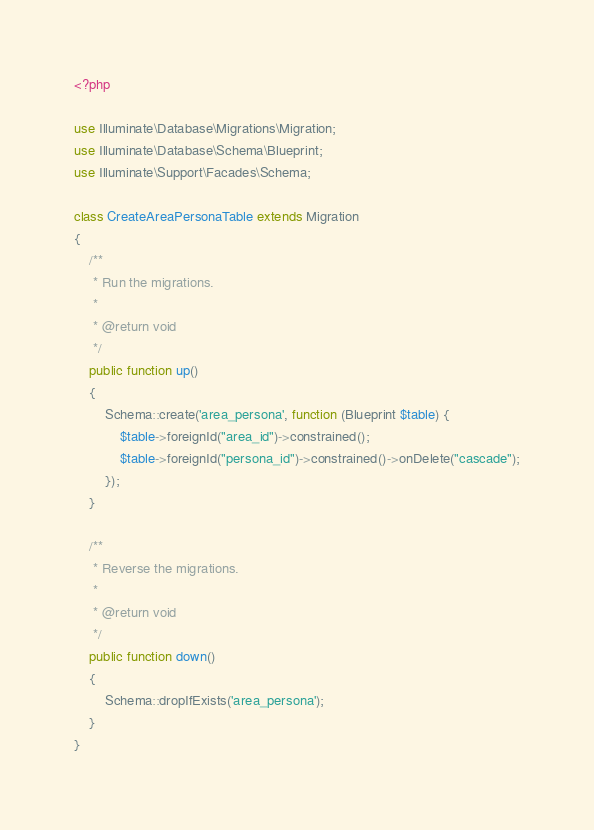Convert code to text. <code><loc_0><loc_0><loc_500><loc_500><_PHP_><?php

use Illuminate\Database\Migrations\Migration;
use Illuminate\Database\Schema\Blueprint;
use Illuminate\Support\Facades\Schema;

class CreateAreaPersonaTable extends Migration
{
    /**
     * Run the migrations.
     *
     * @return void
     */
    public function up()
    {
        Schema::create('area_persona', function (Blueprint $table) {
            $table->foreignId("area_id")->constrained();
            $table->foreignId("persona_id")->constrained()->onDelete("cascade");
        });
    }

    /**
     * Reverse the migrations.
     *
     * @return void
     */
    public function down()
    {
        Schema::dropIfExists('area_persona');
    }
}
</code> 